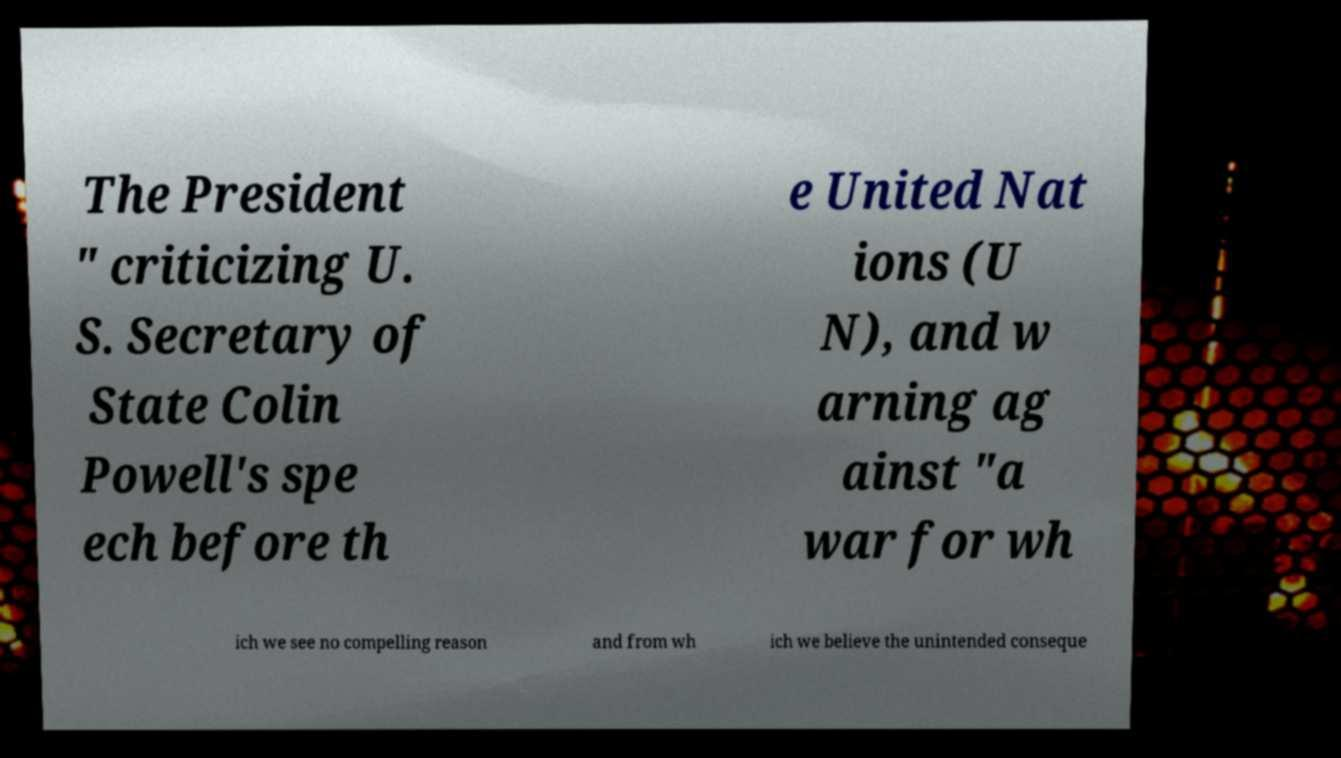Can you accurately transcribe the text from the provided image for me? The President " criticizing U. S. Secretary of State Colin Powell's spe ech before th e United Nat ions (U N), and w arning ag ainst "a war for wh ich we see no compelling reason and from wh ich we believe the unintended conseque 